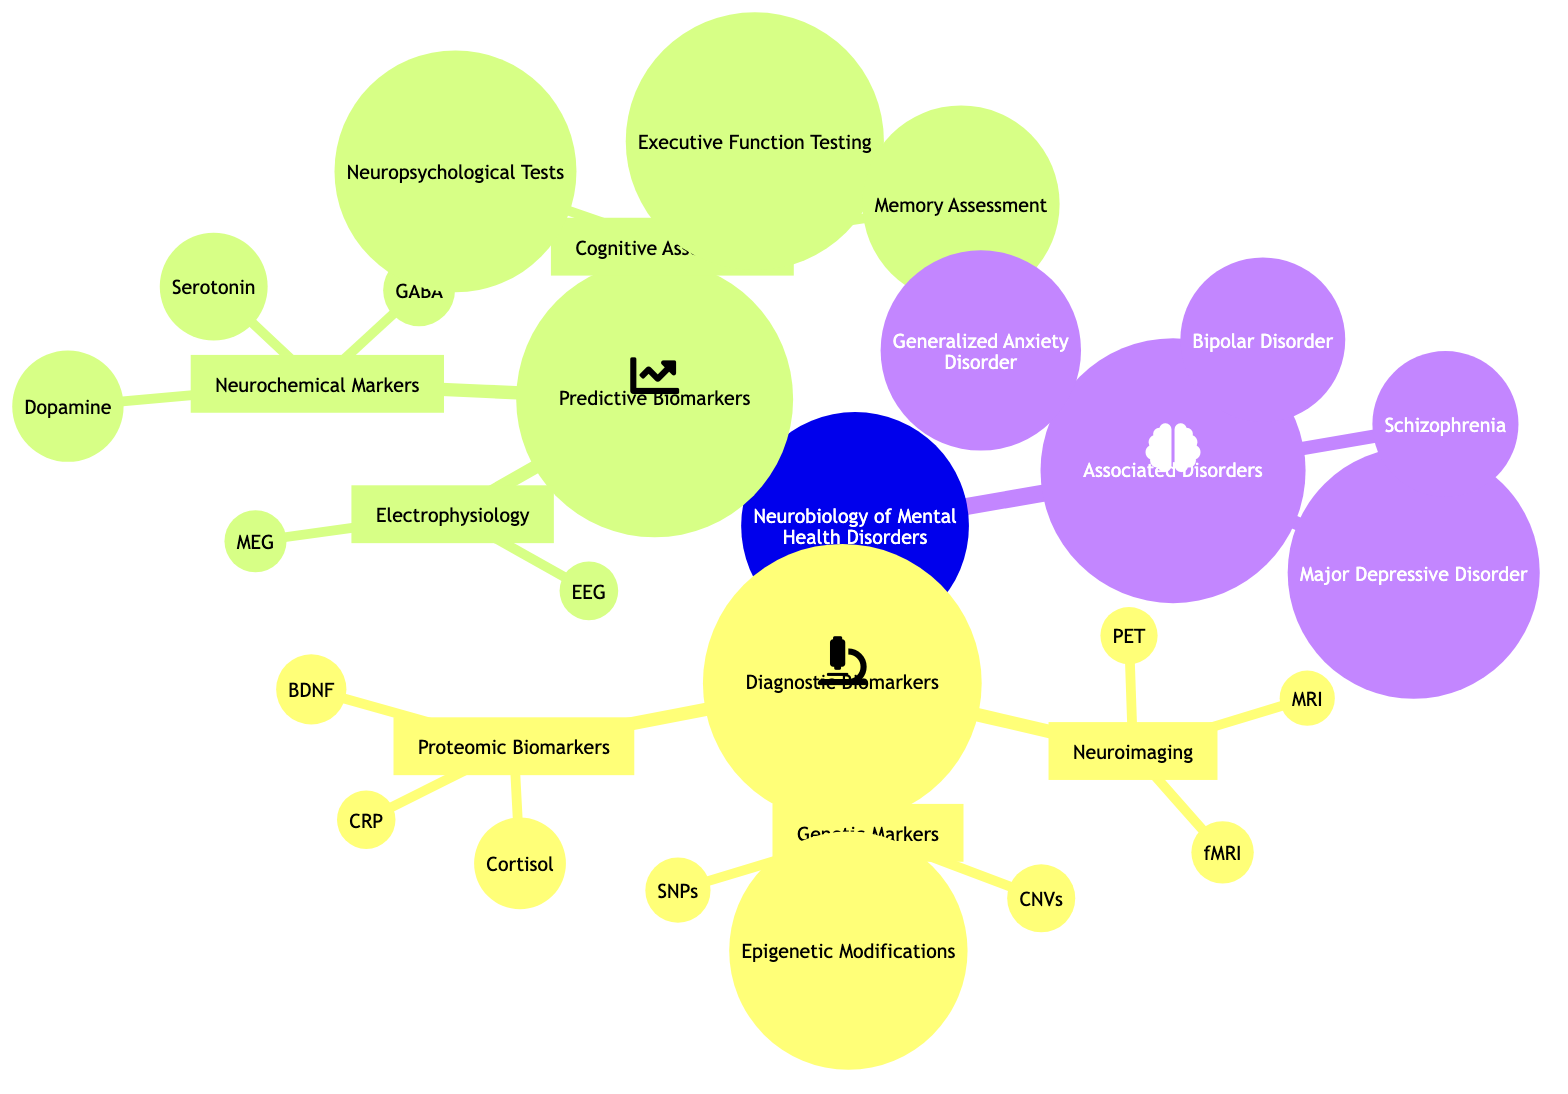What are the three types of diagnostic biomarkers listed? The diagram lists three categories under diagnostic biomarkers: neuroimaging, genetic markers, and proteomic biomarkers.
Answer: neuroimaging, genetic markers, proteomic biomarkers How many neuroimaging techniques are mentioned? Under the diagnostic biomarkers section, there are three neuroimaging techniques listed: MRI, fMRI, and PET.
Answer: 3 Which two electrolytic studies are considered predictive biomarkers? The predictive biomarkers section shows two electrophysiological studies listed: EEG and MEG.
Answer: EEG, MEG What is the relationship between neurochemical markers and cognitive assessments? Both neurochemical markers and cognitive assessments are part of the predictive biomarkers cluster, indicating they are both used to predict mental health outcomes.
Answer: Part of predictive biomarkers Name one associated disorder mentioned in the diagram. The associated disorders section lists several, and one example provided is Major Depressive Disorder.
Answer: Major Depressive Disorder Which type of biomarker includes C-Reactive Protein? C-Reactive Protein is categorized under proteomic biomarkers in the diagnostic biomarkers section.
Answer: Proteomic biomarkers Which genetic marker type has three specific categories? The genetic markers section lists three types: Single Nucleotide Polymorphisms (SNPs), Copy Number Variations (CNVs), and Epigenetic Modifications.
Answer: Genetic markers How many categories are there under predictive biomarkers? The predictive biomarkers section contains three categories: electrophysiology, neurochemical markers, and cognitive assessments.
Answer: 3 Which neurochemical markers are included in the predictive biomarkers? The diagram lists three neurochemical markers: Serotonin, Dopamine, and Gamma-Aminobutyric Acid (GABA).
Answer: Serotonin, Dopamine, GABA 